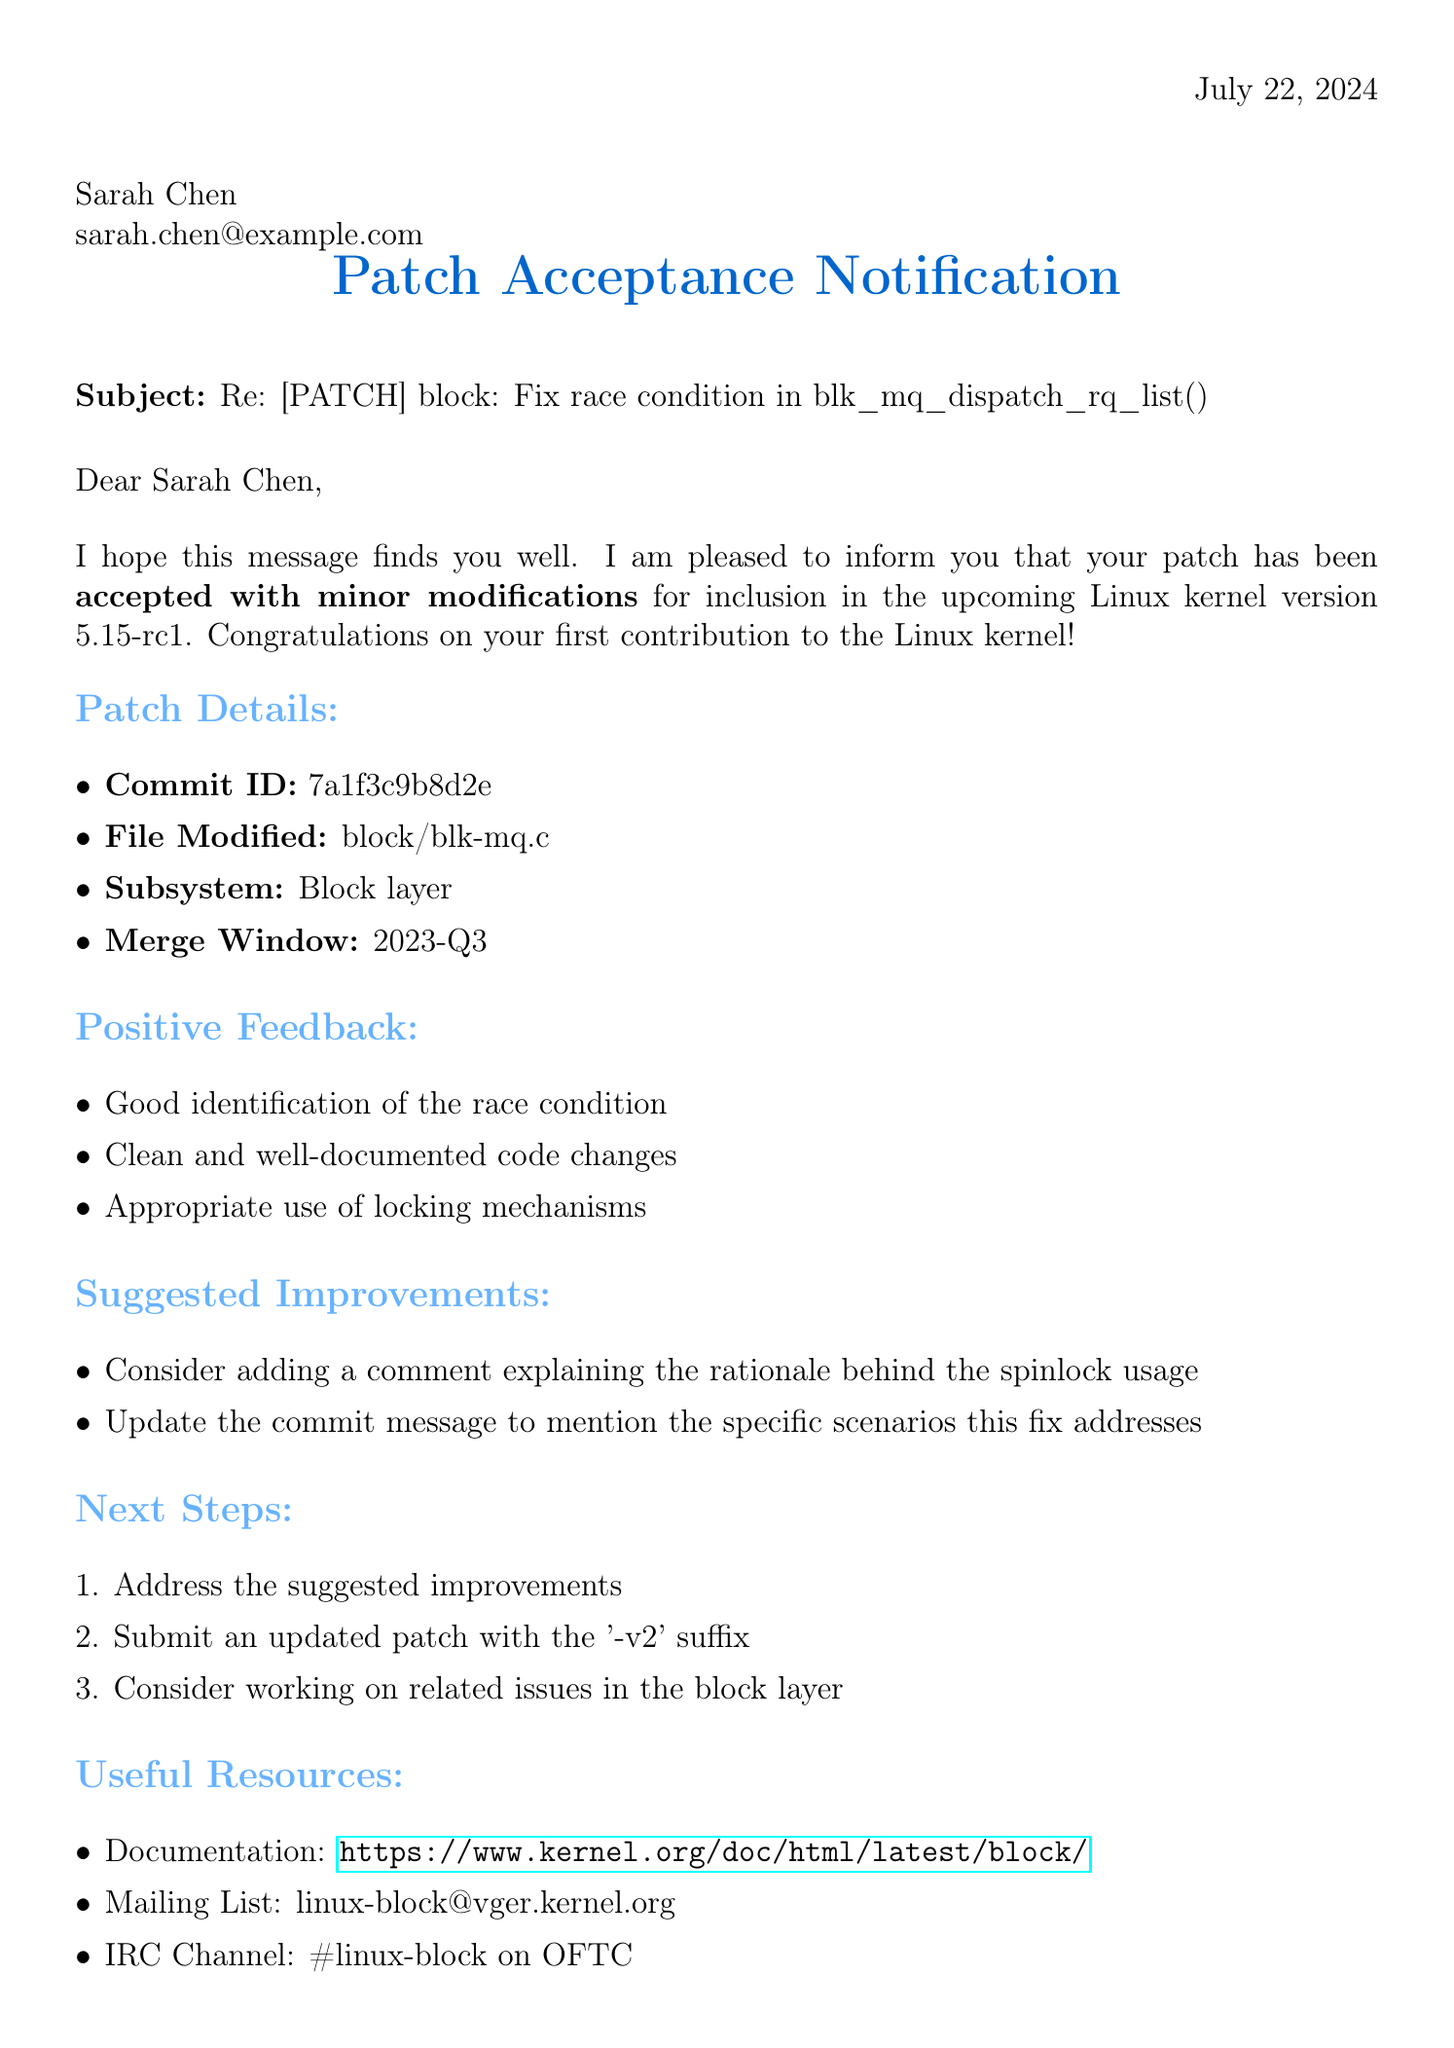What is the name of the recipient? The recipient of the letter is mentioned as Sarah Chen.
Answer: Sarah Chen What is the email address of the sender? The sender’s email address is provided in the document.
Answer: axboe@kernel.dk What is the kernel version mentioned in the acceptance details? The kernel version that the patch will be included in is specified.
Answer: 5.15-rc1 What is the commit ID for the accepted patch? The document lists the commit ID associated with the patch submission.
Answer: 7a1f3c9b8d2e What are the positive points listed in the feedback? The document enumerates several positive points regarding the patch submission.
Answer: Good identification of the race condition What improvements are suggested in the feedback? The suggested improvements are detailed in the document context.
Answer: Consider adding a comment explaining the rationale behind the spinlock usage Who is the mentor suggested for future contributions? A potential mentor is mentioned in the letter along with their email.
Answer: Christoph Hellwig What is the subject line of the letter? The subject of the letter is provided as a specific line.
Answer: Re: [PATCH] block: Fix race condition in blk_mq_dispatch_rq_list() What was the acceptance status of the patch? The status of acceptance is clearly stated in the document.
Answer: Accepted with minor modifications What document type is this? The structure and content of the letter indicate its type.
Answer: Notification letter 